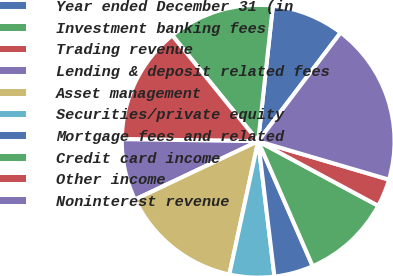Convert chart. <chart><loc_0><loc_0><loc_500><loc_500><pie_chart><fcel>Year ended December 31 (in<fcel>Investment banking fees<fcel>Trading revenue<fcel>Lending & deposit related fees<fcel>Asset management<fcel>Securities/private equity<fcel>Mortgage fees and related<fcel>Credit card income<fcel>Other income<fcel>Noninterest revenue<nl><fcel>8.61%<fcel>12.58%<fcel>13.91%<fcel>7.28%<fcel>14.57%<fcel>5.3%<fcel>4.64%<fcel>10.6%<fcel>3.31%<fcel>19.21%<nl></chart> 